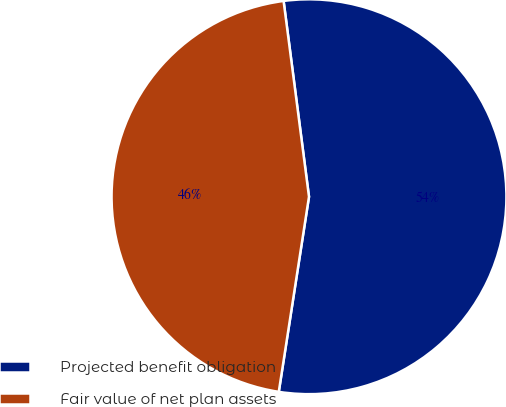Convert chart to OTSL. <chart><loc_0><loc_0><loc_500><loc_500><pie_chart><fcel>Projected benefit obligation<fcel>Fair value of net plan assets<nl><fcel>54.5%<fcel>45.5%<nl></chart> 